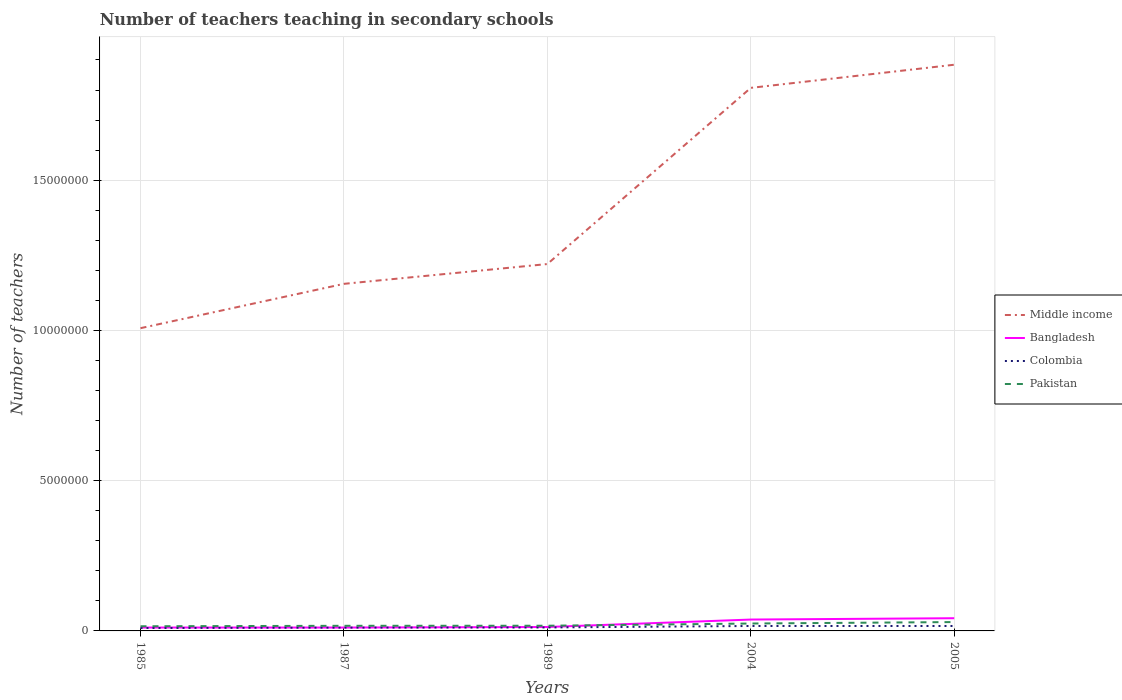Is the number of lines equal to the number of legend labels?
Provide a short and direct response. Yes. Across all years, what is the maximum number of teachers teaching in secondary schools in Pakistan?
Make the answer very short. 1.55e+05. In which year was the number of teachers teaching in secondary schools in Bangladesh maximum?
Keep it short and to the point. 1987. What is the total number of teachers teaching in secondary schools in Pakistan in the graph?
Provide a succinct answer. -4.81e+04. What is the difference between the highest and the second highest number of teachers teaching in secondary schools in Bangladesh?
Offer a terse response. 3.10e+05. What is the difference between two consecutive major ticks on the Y-axis?
Your answer should be compact. 5.00e+06. Are the values on the major ticks of Y-axis written in scientific E-notation?
Your answer should be compact. No. Does the graph contain any zero values?
Provide a succinct answer. No. What is the title of the graph?
Your answer should be very brief. Number of teachers teaching in secondary schools. Does "Nicaragua" appear as one of the legend labels in the graph?
Provide a short and direct response. No. What is the label or title of the Y-axis?
Provide a succinct answer. Number of teachers. What is the Number of teachers in Middle income in 1985?
Your answer should be compact. 1.01e+07. What is the Number of teachers of Bangladesh in 1985?
Offer a terse response. 1.13e+05. What is the Number of teachers of Colombia in 1985?
Give a very brief answer. 9.60e+04. What is the Number of teachers in Pakistan in 1985?
Your answer should be compact. 1.55e+05. What is the Number of teachers of Middle income in 1987?
Give a very brief answer. 1.16e+07. What is the Number of teachers in Bangladesh in 1987?
Make the answer very short. 1.13e+05. What is the Number of teachers in Colombia in 1987?
Offer a terse response. 1.10e+05. What is the Number of teachers of Pakistan in 1987?
Provide a succinct answer. 1.70e+05. What is the Number of teachers of Middle income in 1989?
Your answer should be very brief. 1.22e+07. What is the Number of teachers in Bangladesh in 1989?
Keep it short and to the point. 1.30e+05. What is the Number of teachers in Colombia in 1989?
Your response must be concise. 1.15e+05. What is the Number of teachers in Pakistan in 1989?
Ensure brevity in your answer.  1.73e+05. What is the Number of teachers of Middle income in 2004?
Your answer should be very brief. 1.81e+07. What is the Number of teachers in Bangladesh in 2004?
Provide a succinct answer. 3.78e+05. What is the Number of teachers in Colombia in 2004?
Provide a succinct answer. 1.64e+05. What is the Number of teachers in Pakistan in 2004?
Your response must be concise. 2.47e+05. What is the Number of teachers in Middle income in 2005?
Ensure brevity in your answer.  1.88e+07. What is the Number of teachers in Bangladesh in 2005?
Your answer should be very brief. 4.23e+05. What is the Number of teachers of Colombia in 2005?
Keep it short and to the point. 1.64e+05. What is the Number of teachers of Pakistan in 2005?
Your response must be concise. 2.95e+05. Across all years, what is the maximum Number of teachers of Middle income?
Provide a succinct answer. 1.88e+07. Across all years, what is the maximum Number of teachers in Bangladesh?
Keep it short and to the point. 4.23e+05. Across all years, what is the maximum Number of teachers of Colombia?
Your answer should be compact. 1.64e+05. Across all years, what is the maximum Number of teachers in Pakistan?
Give a very brief answer. 2.95e+05. Across all years, what is the minimum Number of teachers in Middle income?
Give a very brief answer. 1.01e+07. Across all years, what is the minimum Number of teachers in Bangladesh?
Provide a short and direct response. 1.13e+05. Across all years, what is the minimum Number of teachers of Colombia?
Give a very brief answer. 9.60e+04. Across all years, what is the minimum Number of teachers in Pakistan?
Give a very brief answer. 1.55e+05. What is the total Number of teachers in Middle income in the graph?
Offer a very short reply. 7.07e+07. What is the total Number of teachers in Bangladesh in the graph?
Provide a short and direct response. 1.16e+06. What is the total Number of teachers of Colombia in the graph?
Your response must be concise. 6.49e+05. What is the total Number of teachers of Pakistan in the graph?
Ensure brevity in your answer.  1.04e+06. What is the difference between the Number of teachers of Middle income in 1985 and that in 1987?
Offer a very short reply. -1.48e+06. What is the difference between the Number of teachers of Bangladesh in 1985 and that in 1987?
Provide a succinct answer. 181. What is the difference between the Number of teachers of Colombia in 1985 and that in 1987?
Make the answer very short. -1.40e+04. What is the difference between the Number of teachers in Pakistan in 1985 and that in 1987?
Offer a terse response. -1.53e+04. What is the difference between the Number of teachers of Middle income in 1985 and that in 1989?
Your response must be concise. -2.13e+06. What is the difference between the Number of teachers of Bangladesh in 1985 and that in 1989?
Your answer should be very brief. -1.77e+04. What is the difference between the Number of teachers in Colombia in 1985 and that in 1989?
Your answer should be very brief. -1.89e+04. What is the difference between the Number of teachers of Pakistan in 1985 and that in 1989?
Your response must be concise. -1.77e+04. What is the difference between the Number of teachers in Middle income in 1985 and that in 2004?
Your answer should be compact. -8.00e+06. What is the difference between the Number of teachers of Bangladesh in 1985 and that in 2004?
Provide a succinct answer. -2.66e+05. What is the difference between the Number of teachers of Colombia in 1985 and that in 2004?
Make the answer very short. -6.84e+04. What is the difference between the Number of teachers in Pakistan in 1985 and that in 2004?
Your answer should be very brief. -9.14e+04. What is the difference between the Number of teachers of Middle income in 1985 and that in 2005?
Your answer should be very brief. -8.77e+06. What is the difference between the Number of teachers in Bangladesh in 1985 and that in 2005?
Your answer should be very brief. -3.10e+05. What is the difference between the Number of teachers in Colombia in 1985 and that in 2005?
Give a very brief answer. -6.82e+04. What is the difference between the Number of teachers in Pakistan in 1985 and that in 2005?
Keep it short and to the point. -1.40e+05. What is the difference between the Number of teachers in Middle income in 1987 and that in 1989?
Give a very brief answer. -6.59e+05. What is the difference between the Number of teachers in Bangladesh in 1987 and that in 1989?
Keep it short and to the point. -1.79e+04. What is the difference between the Number of teachers of Colombia in 1987 and that in 1989?
Offer a terse response. -4906. What is the difference between the Number of teachers in Pakistan in 1987 and that in 1989?
Offer a very short reply. -2350. What is the difference between the Number of teachers in Middle income in 1987 and that in 2004?
Provide a succinct answer. -6.52e+06. What is the difference between the Number of teachers of Bangladesh in 1987 and that in 2004?
Offer a terse response. -2.66e+05. What is the difference between the Number of teachers of Colombia in 1987 and that in 2004?
Give a very brief answer. -5.44e+04. What is the difference between the Number of teachers in Pakistan in 1987 and that in 2004?
Your answer should be compact. -7.61e+04. What is the difference between the Number of teachers in Middle income in 1987 and that in 2005?
Give a very brief answer. -7.29e+06. What is the difference between the Number of teachers of Bangladesh in 1987 and that in 2005?
Make the answer very short. -3.10e+05. What is the difference between the Number of teachers of Colombia in 1987 and that in 2005?
Your response must be concise. -5.43e+04. What is the difference between the Number of teachers of Pakistan in 1987 and that in 2005?
Your response must be concise. -1.24e+05. What is the difference between the Number of teachers of Middle income in 1989 and that in 2004?
Keep it short and to the point. -5.86e+06. What is the difference between the Number of teachers of Bangladesh in 1989 and that in 2004?
Your answer should be very brief. -2.48e+05. What is the difference between the Number of teachers in Colombia in 1989 and that in 2004?
Ensure brevity in your answer.  -4.95e+04. What is the difference between the Number of teachers in Pakistan in 1989 and that in 2004?
Your answer should be very brief. -7.38e+04. What is the difference between the Number of teachers of Middle income in 1989 and that in 2005?
Provide a succinct answer. -6.63e+06. What is the difference between the Number of teachers in Bangladesh in 1989 and that in 2005?
Your answer should be very brief. -2.92e+05. What is the difference between the Number of teachers of Colombia in 1989 and that in 2005?
Your answer should be compact. -4.94e+04. What is the difference between the Number of teachers of Pakistan in 1989 and that in 2005?
Give a very brief answer. -1.22e+05. What is the difference between the Number of teachers in Middle income in 2004 and that in 2005?
Make the answer very short. -7.70e+05. What is the difference between the Number of teachers in Bangladesh in 2004 and that in 2005?
Keep it short and to the point. -4.43e+04. What is the difference between the Number of teachers in Colombia in 2004 and that in 2005?
Provide a succinct answer. 146. What is the difference between the Number of teachers of Pakistan in 2004 and that in 2005?
Your answer should be very brief. -4.81e+04. What is the difference between the Number of teachers of Middle income in 1985 and the Number of teachers of Bangladesh in 1987?
Give a very brief answer. 9.96e+06. What is the difference between the Number of teachers of Middle income in 1985 and the Number of teachers of Colombia in 1987?
Keep it short and to the point. 9.96e+06. What is the difference between the Number of teachers in Middle income in 1985 and the Number of teachers in Pakistan in 1987?
Offer a very short reply. 9.90e+06. What is the difference between the Number of teachers in Bangladesh in 1985 and the Number of teachers in Colombia in 1987?
Your answer should be very brief. 2767. What is the difference between the Number of teachers of Bangladesh in 1985 and the Number of teachers of Pakistan in 1987?
Keep it short and to the point. -5.77e+04. What is the difference between the Number of teachers in Colombia in 1985 and the Number of teachers in Pakistan in 1987?
Ensure brevity in your answer.  -7.45e+04. What is the difference between the Number of teachers in Middle income in 1985 and the Number of teachers in Bangladesh in 1989?
Provide a succinct answer. 9.94e+06. What is the difference between the Number of teachers in Middle income in 1985 and the Number of teachers in Colombia in 1989?
Provide a short and direct response. 9.96e+06. What is the difference between the Number of teachers in Middle income in 1985 and the Number of teachers in Pakistan in 1989?
Give a very brief answer. 9.90e+06. What is the difference between the Number of teachers in Bangladesh in 1985 and the Number of teachers in Colombia in 1989?
Your answer should be compact. -2139. What is the difference between the Number of teachers of Bangladesh in 1985 and the Number of teachers of Pakistan in 1989?
Ensure brevity in your answer.  -6.01e+04. What is the difference between the Number of teachers in Colombia in 1985 and the Number of teachers in Pakistan in 1989?
Give a very brief answer. -7.68e+04. What is the difference between the Number of teachers of Middle income in 1985 and the Number of teachers of Bangladesh in 2004?
Your response must be concise. 9.70e+06. What is the difference between the Number of teachers in Middle income in 1985 and the Number of teachers in Colombia in 2004?
Keep it short and to the point. 9.91e+06. What is the difference between the Number of teachers of Middle income in 1985 and the Number of teachers of Pakistan in 2004?
Offer a very short reply. 9.83e+06. What is the difference between the Number of teachers in Bangladesh in 1985 and the Number of teachers in Colombia in 2004?
Give a very brief answer. -5.16e+04. What is the difference between the Number of teachers of Bangladesh in 1985 and the Number of teachers of Pakistan in 2004?
Ensure brevity in your answer.  -1.34e+05. What is the difference between the Number of teachers of Colombia in 1985 and the Number of teachers of Pakistan in 2004?
Offer a very short reply. -1.51e+05. What is the difference between the Number of teachers of Middle income in 1985 and the Number of teachers of Bangladesh in 2005?
Ensure brevity in your answer.  9.65e+06. What is the difference between the Number of teachers in Middle income in 1985 and the Number of teachers in Colombia in 2005?
Your answer should be compact. 9.91e+06. What is the difference between the Number of teachers of Middle income in 1985 and the Number of teachers of Pakistan in 2005?
Provide a succinct answer. 9.78e+06. What is the difference between the Number of teachers in Bangladesh in 1985 and the Number of teachers in Colombia in 2005?
Your answer should be very brief. -5.15e+04. What is the difference between the Number of teachers of Bangladesh in 1985 and the Number of teachers of Pakistan in 2005?
Your answer should be very brief. -1.82e+05. What is the difference between the Number of teachers of Colombia in 1985 and the Number of teachers of Pakistan in 2005?
Give a very brief answer. -1.99e+05. What is the difference between the Number of teachers of Middle income in 1987 and the Number of teachers of Bangladesh in 1989?
Keep it short and to the point. 1.14e+07. What is the difference between the Number of teachers in Middle income in 1987 and the Number of teachers in Colombia in 1989?
Your response must be concise. 1.14e+07. What is the difference between the Number of teachers in Middle income in 1987 and the Number of teachers in Pakistan in 1989?
Give a very brief answer. 1.14e+07. What is the difference between the Number of teachers of Bangladesh in 1987 and the Number of teachers of Colombia in 1989?
Keep it short and to the point. -2320. What is the difference between the Number of teachers in Bangladesh in 1987 and the Number of teachers in Pakistan in 1989?
Provide a succinct answer. -6.03e+04. What is the difference between the Number of teachers of Colombia in 1987 and the Number of teachers of Pakistan in 1989?
Ensure brevity in your answer.  -6.29e+04. What is the difference between the Number of teachers in Middle income in 1987 and the Number of teachers in Bangladesh in 2004?
Your response must be concise. 1.12e+07. What is the difference between the Number of teachers in Middle income in 1987 and the Number of teachers in Colombia in 2004?
Give a very brief answer. 1.14e+07. What is the difference between the Number of teachers of Middle income in 1987 and the Number of teachers of Pakistan in 2004?
Your answer should be very brief. 1.13e+07. What is the difference between the Number of teachers in Bangladesh in 1987 and the Number of teachers in Colombia in 2004?
Make the answer very short. -5.18e+04. What is the difference between the Number of teachers of Bangladesh in 1987 and the Number of teachers of Pakistan in 2004?
Your answer should be very brief. -1.34e+05. What is the difference between the Number of teachers of Colombia in 1987 and the Number of teachers of Pakistan in 2004?
Provide a short and direct response. -1.37e+05. What is the difference between the Number of teachers in Middle income in 1987 and the Number of teachers in Bangladesh in 2005?
Offer a terse response. 1.11e+07. What is the difference between the Number of teachers of Middle income in 1987 and the Number of teachers of Colombia in 2005?
Ensure brevity in your answer.  1.14e+07. What is the difference between the Number of teachers of Middle income in 1987 and the Number of teachers of Pakistan in 2005?
Make the answer very short. 1.13e+07. What is the difference between the Number of teachers of Bangladesh in 1987 and the Number of teachers of Colombia in 2005?
Offer a very short reply. -5.17e+04. What is the difference between the Number of teachers in Bangladesh in 1987 and the Number of teachers in Pakistan in 2005?
Provide a succinct answer. -1.82e+05. What is the difference between the Number of teachers in Colombia in 1987 and the Number of teachers in Pakistan in 2005?
Keep it short and to the point. -1.85e+05. What is the difference between the Number of teachers of Middle income in 1989 and the Number of teachers of Bangladesh in 2004?
Your answer should be compact. 1.18e+07. What is the difference between the Number of teachers in Middle income in 1989 and the Number of teachers in Colombia in 2004?
Provide a succinct answer. 1.20e+07. What is the difference between the Number of teachers in Middle income in 1989 and the Number of teachers in Pakistan in 2004?
Provide a succinct answer. 1.20e+07. What is the difference between the Number of teachers in Bangladesh in 1989 and the Number of teachers in Colombia in 2004?
Your response must be concise. -3.39e+04. What is the difference between the Number of teachers in Bangladesh in 1989 and the Number of teachers in Pakistan in 2004?
Your response must be concise. -1.16e+05. What is the difference between the Number of teachers in Colombia in 1989 and the Number of teachers in Pakistan in 2004?
Your response must be concise. -1.32e+05. What is the difference between the Number of teachers in Middle income in 1989 and the Number of teachers in Bangladesh in 2005?
Offer a very short reply. 1.18e+07. What is the difference between the Number of teachers of Middle income in 1989 and the Number of teachers of Colombia in 2005?
Offer a very short reply. 1.20e+07. What is the difference between the Number of teachers in Middle income in 1989 and the Number of teachers in Pakistan in 2005?
Your answer should be compact. 1.19e+07. What is the difference between the Number of teachers of Bangladesh in 1989 and the Number of teachers of Colombia in 2005?
Offer a terse response. -3.38e+04. What is the difference between the Number of teachers of Bangladesh in 1989 and the Number of teachers of Pakistan in 2005?
Your response must be concise. -1.64e+05. What is the difference between the Number of teachers of Colombia in 1989 and the Number of teachers of Pakistan in 2005?
Offer a very short reply. -1.80e+05. What is the difference between the Number of teachers of Middle income in 2004 and the Number of teachers of Bangladesh in 2005?
Provide a short and direct response. 1.76e+07. What is the difference between the Number of teachers of Middle income in 2004 and the Number of teachers of Colombia in 2005?
Give a very brief answer. 1.79e+07. What is the difference between the Number of teachers in Middle income in 2004 and the Number of teachers in Pakistan in 2005?
Offer a very short reply. 1.78e+07. What is the difference between the Number of teachers of Bangladesh in 2004 and the Number of teachers of Colombia in 2005?
Give a very brief answer. 2.14e+05. What is the difference between the Number of teachers of Bangladesh in 2004 and the Number of teachers of Pakistan in 2005?
Ensure brevity in your answer.  8.36e+04. What is the difference between the Number of teachers of Colombia in 2004 and the Number of teachers of Pakistan in 2005?
Make the answer very short. -1.30e+05. What is the average Number of teachers in Middle income per year?
Your answer should be very brief. 1.41e+07. What is the average Number of teachers of Bangladesh per year?
Provide a short and direct response. 2.31e+05. What is the average Number of teachers of Colombia per year?
Ensure brevity in your answer.  1.30e+05. What is the average Number of teachers of Pakistan per year?
Your answer should be very brief. 2.08e+05. In the year 1985, what is the difference between the Number of teachers in Middle income and Number of teachers in Bangladesh?
Make the answer very short. 9.96e+06. In the year 1985, what is the difference between the Number of teachers of Middle income and Number of teachers of Colombia?
Offer a very short reply. 9.98e+06. In the year 1985, what is the difference between the Number of teachers in Middle income and Number of teachers in Pakistan?
Offer a terse response. 9.92e+06. In the year 1985, what is the difference between the Number of teachers of Bangladesh and Number of teachers of Colombia?
Provide a short and direct response. 1.67e+04. In the year 1985, what is the difference between the Number of teachers of Bangladesh and Number of teachers of Pakistan?
Your answer should be very brief. -4.24e+04. In the year 1985, what is the difference between the Number of teachers in Colombia and Number of teachers in Pakistan?
Ensure brevity in your answer.  -5.92e+04. In the year 1987, what is the difference between the Number of teachers of Middle income and Number of teachers of Bangladesh?
Keep it short and to the point. 1.14e+07. In the year 1987, what is the difference between the Number of teachers in Middle income and Number of teachers in Colombia?
Ensure brevity in your answer.  1.14e+07. In the year 1987, what is the difference between the Number of teachers in Middle income and Number of teachers in Pakistan?
Your answer should be very brief. 1.14e+07. In the year 1987, what is the difference between the Number of teachers in Bangladesh and Number of teachers in Colombia?
Ensure brevity in your answer.  2586. In the year 1987, what is the difference between the Number of teachers in Bangladesh and Number of teachers in Pakistan?
Offer a terse response. -5.79e+04. In the year 1987, what is the difference between the Number of teachers of Colombia and Number of teachers of Pakistan?
Your answer should be compact. -6.05e+04. In the year 1989, what is the difference between the Number of teachers in Middle income and Number of teachers in Bangladesh?
Your answer should be very brief. 1.21e+07. In the year 1989, what is the difference between the Number of teachers of Middle income and Number of teachers of Colombia?
Make the answer very short. 1.21e+07. In the year 1989, what is the difference between the Number of teachers of Middle income and Number of teachers of Pakistan?
Ensure brevity in your answer.  1.20e+07. In the year 1989, what is the difference between the Number of teachers of Bangladesh and Number of teachers of Colombia?
Your response must be concise. 1.56e+04. In the year 1989, what is the difference between the Number of teachers in Bangladesh and Number of teachers in Pakistan?
Provide a succinct answer. -4.24e+04. In the year 1989, what is the difference between the Number of teachers in Colombia and Number of teachers in Pakistan?
Ensure brevity in your answer.  -5.80e+04. In the year 2004, what is the difference between the Number of teachers in Middle income and Number of teachers in Bangladesh?
Give a very brief answer. 1.77e+07. In the year 2004, what is the difference between the Number of teachers of Middle income and Number of teachers of Colombia?
Keep it short and to the point. 1.79e+07. In the year 2004, what is the difference between the Number of teachers in Middle income and Number of teachers in Pakistan?
Your answer should be very brief. 1.78e+07. In the year 2004, what is the difference between the Number of teachers of Bangladesh and Number of teachers of Colombia?
Offer a very short reply. 2.14e+05. In the year 2004, what is the difference between the Number of teachers of Bangladesh and Number of teachers of Pakistan?
Provide a short and direct response. 1.32e+05. In the year 2004, what is the difference between the Number of teachers of Colombia and Number of teachers of Pakistan?
Offer a very short reply. -8.22e+04. In the year 2005, what is the difference between the Number of teachers in Middle income and Number of teachers in Bangladesh?
Your response must be concise. 1.84e+07. In the year 2005, what is the difference between the Number of teachers in Middle income and Number of teachers in Colombia?
Provide a succinct answer. 1.87e+07. In the year 2005, what is the difference between the Number of teachers of Middle income and Number of teachers of Pakistan?
Give a very brief answer. 1.85e+07. In the year 2005, what is the difference between the Number of teachers in Bangladesh and Number of teachers in Colombia?
Offer a terse response. 2.58e+05. In the year 2005, what is the difference between the Number of teachers in Bangladesh and Number of teachers in Pakistan?
Keep it short and to the point. 1.28e+05. In the year 2005, what is the difference between the Number of teachers in Colombia and Number of teachers in Pakistan?
Provide a succinct answer. -1.31e+05. What is the ratio of the Number of teachers in Middle income in 1985 to that in 1987?
Keep it short and to the point. 0.87. What is the ratio of the Number of teachers in Bangladesh in 1985 to that in 1987?
Offer a terse response. 1. What is the ratio of the Number of teachers of Colombia in 1985 to that in 1987?
Your answer should be compact. 0.87. What is the ratio of the Number of teachers in Pakistan in 1985 to that in 1987?
Your response must be concise. 0.91. What is the ratio of the Number of teachers in Middle income in 1985 to that in 1989?
Your answer should be very brief. 0.83. What is the ratio of the Number of teachers of Bangladesh in 1985 to that in 1989?
Your answer should be very brief. 0.86. What is the ratio of the Number of teachers of Colombia in 1985 to that in 1989?
Give a very brief answer. 0.84. What is the ratio of the Number of teachers in Pakistan in 1985 to that in 1989?
Provide a succinct answer. 0.9. What is the ratio of the Number of teachers in Middle income in 1985 to that in 2004?
Offer a very short reply. 0.56. What is the ratio of the Number of teachers of Bangladesh in 1985 to that in 2004?
Your answer should be very brief. 0.3. What is the ratio of the Number of teachers of Colombia in 1985 to that in 2004?
Your answer should be very brief. 0.58. What is the ratio of the Number of teachers of Pakistan in 1985 to that in 2004?
Offer a very short reply. 0.63. What is the ratio of the Number of teachers of Middle income in 1985 to that in 2005?
Your answer should be very brief. 0.53. What is the ratio of the Number of teachers in Bangladesh in 1985 to that in 2005?
Your answer should be compact. 0.27. What is the ratio of the Number of teachers in Colombia in 1985 to that in 2005?
Make the answer very short. 0.58. What is the ratio of the Number of teachers in Pakistan in 1985 to that in 2005?
Make the answer very short. 0.53. What is the ratio of the Number of teachers in Middle income in 1987 to that in 1989?
Give a very brief answer. 0.95. What is the ratio of the Number of teachers in Bangladesh in 1987 to that in 1989?
Offer a terse response. 0.86. What is the ratio of the Number of teachers in Colombia in 1987 to that in 1989?
Make the answer very short. 0.96. What is the ratio of the Number of teachers of Pakistan in 1987 to that in 1989?
Your response must be concise. 0.99. What is the ratio of the Number of teachers in Middle income in 1987 to that in 2004?
Ensure brevity in your answer.  0.64. What is the ratio of the Number of teachers of Bangladesh in 1987 to that in 2004?
Your answer should be compact. 0.3. What is the ratio of the Number of teachers in Colombia in 1987 to that in 2004?
Offer a terse response. 0.67. What is the ratio of the Number of teachers of Pakistan in 1987 to that in 2004?
Offer a very short reply. 0.69. What is the ratio of the Number of teachers of Middle income in 1987 to that in 2005?
Provide a short and direct response. 0.61. What is the ratio of the Number of teachers of Bangladesh in 1987 to that in 2005?
Provide a succinct answer. 0.27. What is the ratio of the Number of teachers in Colombia in 1987 to that in 2005?
Your answer should be compact. 0.67. What is the ratio of the Number of teachers of Pakistan in 1987 to that in 2005?
Ensure brevity in your answer.  0.58. What is the ratio of the Number of teachers in Middle income in 1989 to that in 2004?
Make the answer very short. 0.68. What is the ratio of the Number of teachers of Bangladesh in 1989 to that in 2004?
Offer a very short reply. 0.34. What is the ratio of the Number of teachers of Colombia in 1989 to that in 2004?
Your response must be concise. 0.7. What is the ratio of the Number of teachers in Pakistan in 1989 to that in 2004?
Provide a succinct answer. 0.7. What is the ratio of the Number of teachers of Middle income in 1989 to that in 2005?
Provide a succinct answer. 0.65. What is the ratio of the Number of teachers of Bangladesh in 1989 to that in 2005?
Your answer should be compact. 0.31. What is the ratio of the Number of teachers in Colombia in 1989 to that in 2005?
Offer a very short reply. 0.7. What is the ratio of the Number of teachers of Pakistan in 1989 to that in 2005?
Keep it short and to the point. 0.59. What is the ratio of the Number of teachers in Middle income in 2004 to that in 2005?
Keep it short and to the point. 0.96. What is the ratio of the Number of teachers in Bangladesh in 2004 to that in 2005?
Offer a terse response. 0.9. What is the ratio of the Number of teachers in Pakistan in 2004 to that in 2005?
Ensure brevity in your answer.  0.84. What is the difference between the highest and the second highest Number of teachers in Middle income?
Give a very brief answer. 7.70e+05. What is the difference between the highest and the second highest Number of teachers of Bangladesh?
Offer a terse response. 4.43e+04. What is the difference between the highest and the second highest Number of teachers in Colombia?
Your answer should be very brief. 146. What is the difference between the highest and the second highest Number of teachers in Pakistan?
Provide a short and direct response. 4.81e+04. What is the difference between the highest and the lowest Number of teachers of Middle income?
Give a very brief answer. 8.77e+06. What is the difference between the highest and the lowest Number of teachers in Bangladesh?
Offer a very short reply. 3.10e+05. What is the difference between the highest and the lowest Number of teachers in Colombia?
Give a very brief answer. 6.84e+04. What is the difference between the highest and the lowest Number of teachers of Pakistan?
Keep it short and to the point. 1.40e+05. 